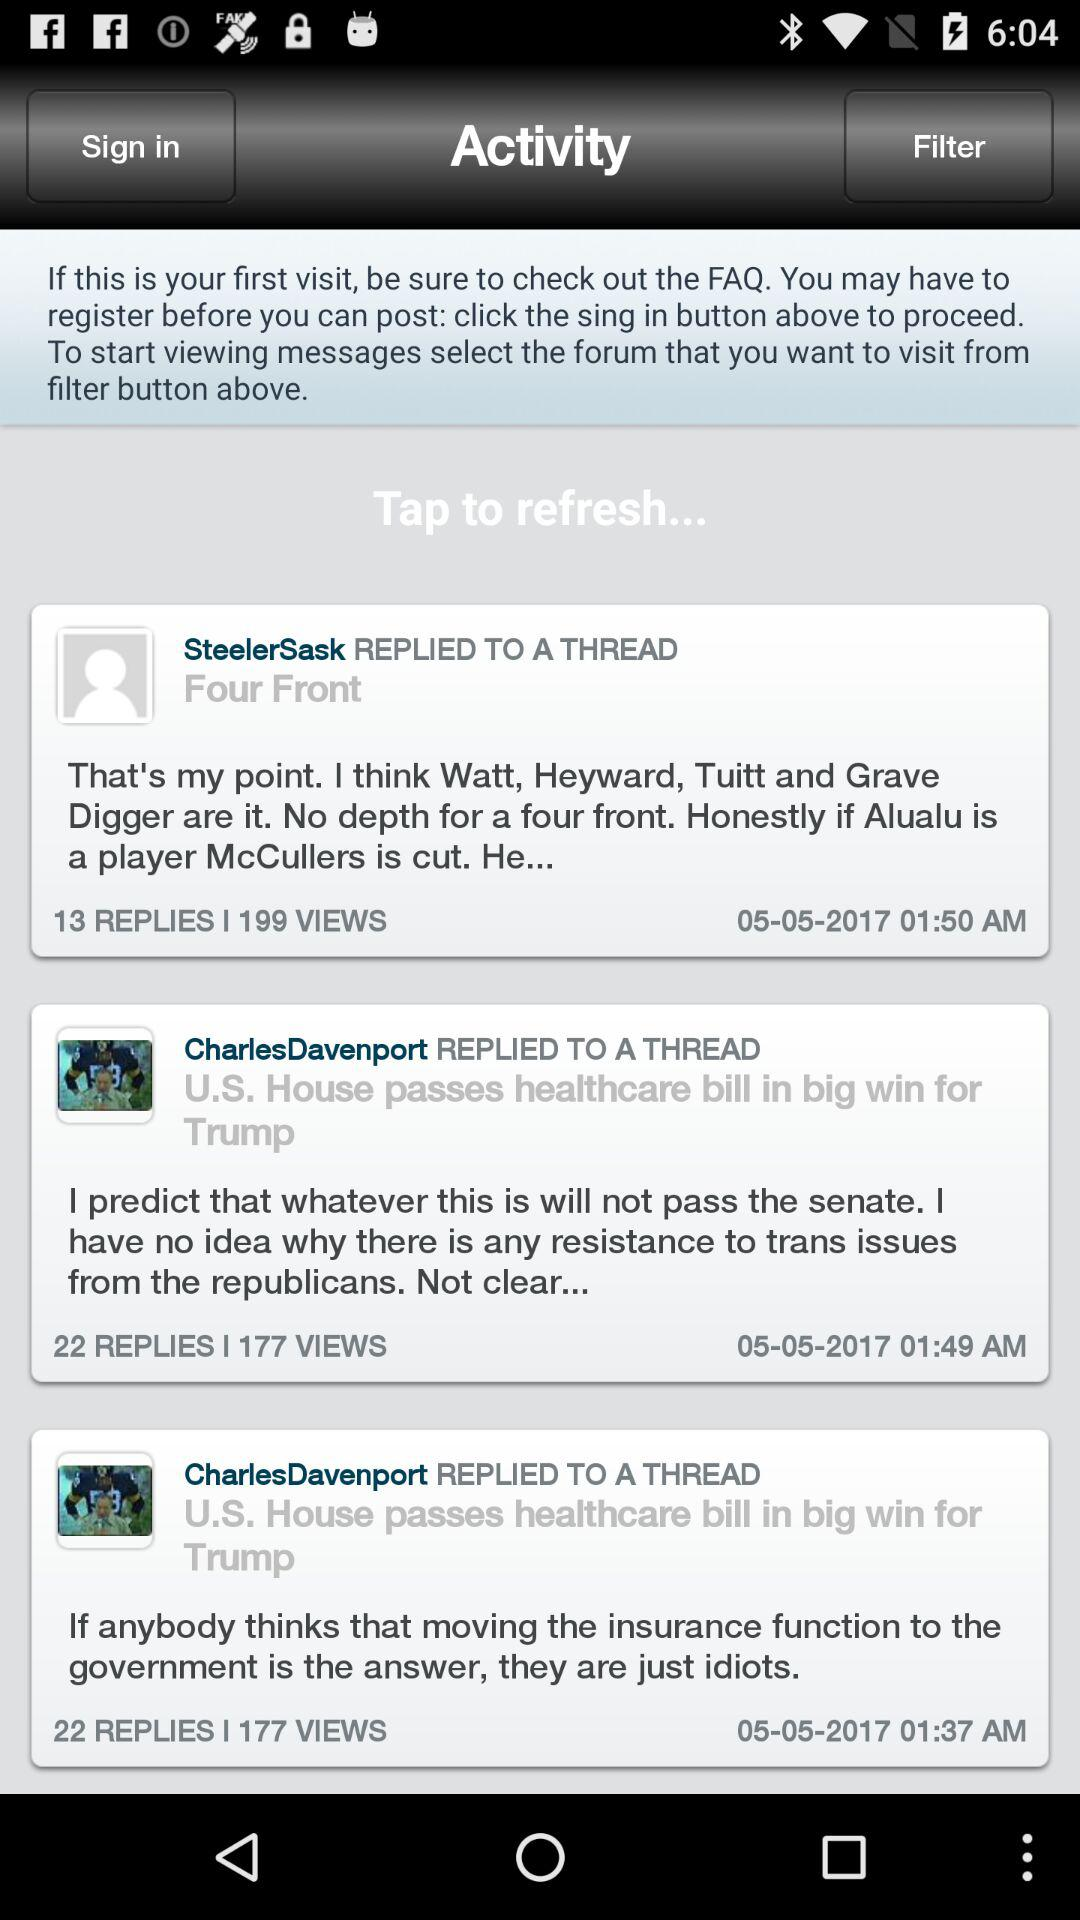How many views on CharlesDevenport post? There are 177 views. 